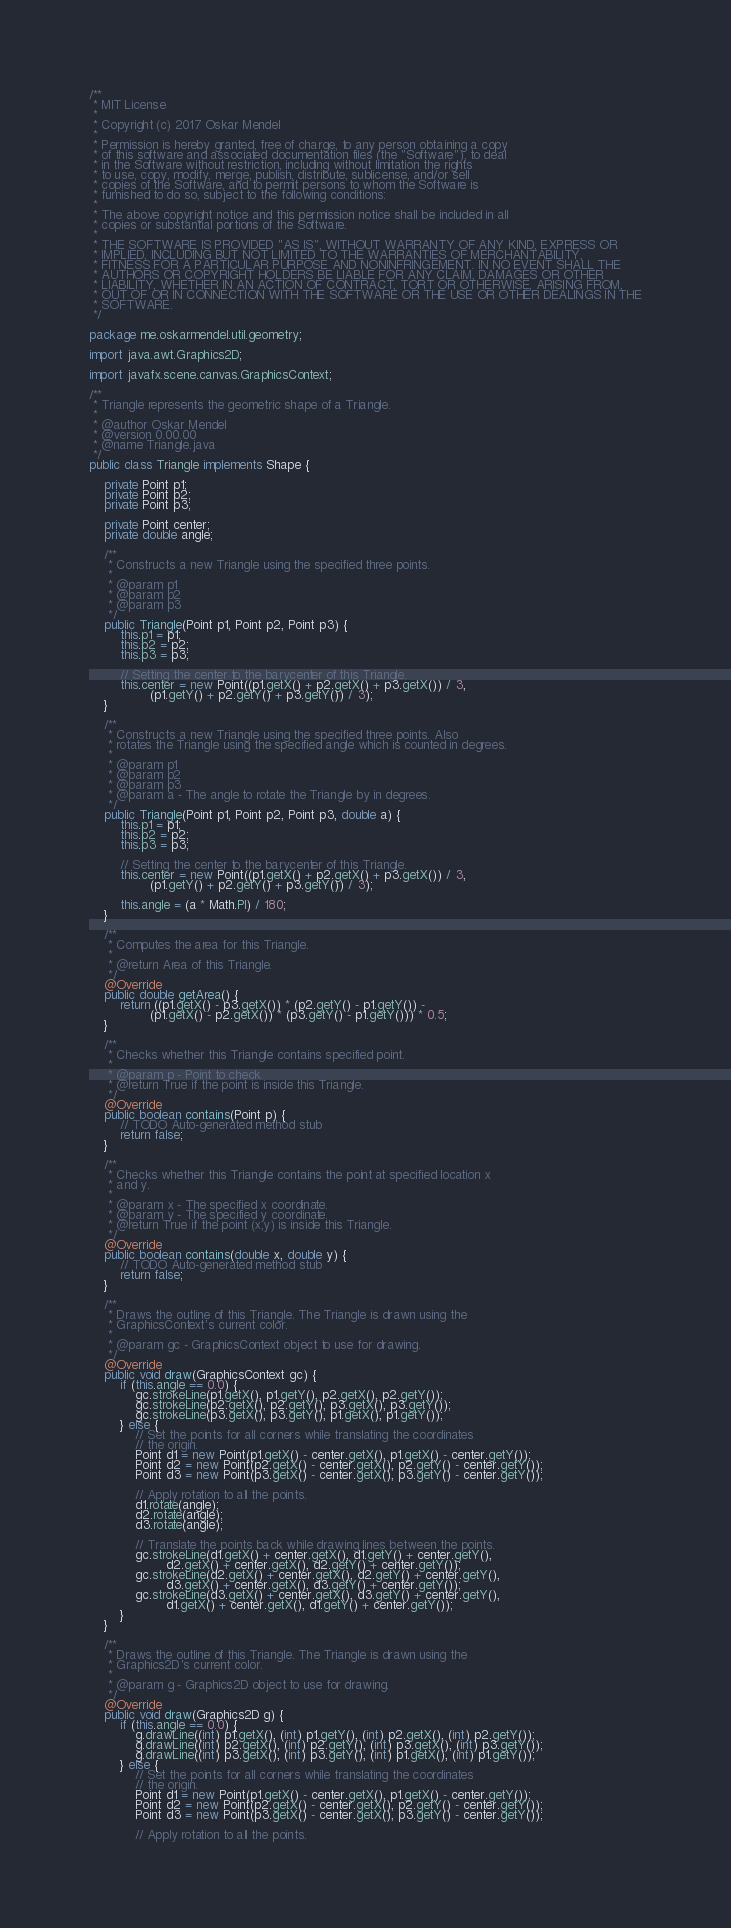<code> <loc_0><loc_0><loc_500><loc_500><_Java_>/**
 * MIT License
 * 
 * Copyright (c) 2017 Oskar Mendel
 * 
 * Permission is hereby granted, free of charge, to any person obtaining a copy
 * of this software and associated documentation files (the "Software"), to deal
 * in the Software without restriction, including without limitation the rights
 * to use, copy, modify, merge, publish, distribute, sublicense, and/or sell
 * copies of the Software, and to permit persons to whom the Software is
 * furnished to do so, subject to the following conditions:
 * 
 * The above copyright notice and this permission notice shall be included in all
 * copies or substantial portions of the Software.
 * 
 * THE SOFTWARE IS PROVIDED "AS IS", WITHOUT WARRANTY OF ANY KIND, EXPRESS OR
 * IMPLIED, INCLUDING BUT NOT LIMITED TO THE WARRANTIES OF MERCHANTABILITY,
 * FITNESS FOR A PARTICULAR PURPOSE AND NONINFRINGEMENT. IN NO EVENT SHALL THE
 * AUTHORS OR COPYRIGHT HOLDERS BE LIABLE FOR ANY CLAIM, DAMAGES OR OTHER
 * LIABILITY, WHETHER IN AN ACTION OF CONTRACT, TORT OR OTHERWISE, ARISING FROM,
 * OUT OF OR IN CONNECTION WITH THE SOFTWARE OR THE USE OR OTHER DEALINGS IN THE
 * SOFTWARE.
 */

package me.oskarmendel.util.geometry;

import java.awt.Graphics2D;

import javafx.scene.canvas.GraphicsContext;

/**
 * Triangle represents the geometric shape of a Triangle.
 * 
 * @author Oskar Mendel
 * @version 0.00.00
 * @name Triangle.java
 */
public class Triangle implements Shape {

	private Point p1;
	private Point p2;
	private Point p3;
	
	private Point center;
	private double angle;
	
	/**
	 * Constructs a new Triangle using the specified three points.
	 * 
	 * @param p1
	 * @param p2
	 * @param p3
	 */
	public Triangle(Point p1, Point p2, Point p3) {
		this.p1 = p1;
		this.p2 = p2;
		this.p3 = p3;
		
		// Setting the center to the barycenter of this Triangle.
		this.center = new Point((p1.getX() + p2.getX() + p3.getX()) / 3,
				(p1.getY() + p2.getY() + p3.getY()) / 3);
	}
	
	/**
	 * Constructs a new Triangle using the specified three points. Also
	 * rotates the Triangle using the specified angle which is counted in degrees.
	 * 
	 * @param p1
	 * @param p2
	 * @param p3
	 * @param a - The angle to rotate the Triangle by in degrees.
	 */
	public Triangle(Point p1, Point p2, Point p3, double a) {
		this.p1 = p1;
		this.p2 = p2;
		this.p3 = p3;
		
		// Setting the center to the barycenter of this Triangle.
		this.center = new Point((p1.getX() + p2.getX() + p3.getX()) / 3,
				(p1.getY() + p2.getY() + p3.getY()) / 3);
		
		this.angle = (a * Math.PI) / 180;
	}
	
	/**
	 * Computes the area for this Triangle.
	 * 
	 * @return Area of this Triangle.
	 */
	@Override
	public double getArea() {
		return ((p1.getX() - p3.getX()) * (p2.getY() - p1.getY()) -
				(p1.getX() - p2.getX()) * (p3.getY() - p1.getY())) * 0.5;
	}

	/**
	 * Checks whether this Triangle contains specified point.
	 * 
	 * @param p - Point to check.
	 * @return True if the point is inside this Triangle.
	 */
	@Override
	public boolean contains(Point p) {
		// TODO Auto-generated method stub
		return false;
	}

	/**
	 * Checks whether this Triangle contains the point at specified location x
	 * and y.
	 * 
	 * @param x - The specified x coordinate.
	 * @param y - The specified y coordinate.
	 * @return True if the point (x,y) is inside this Triangle.
	 */
	@Override
	public boolean contains(double x, double y) {
		// TODO Auto-generated method stub
		return false;
	}

	/**
	 * Draws the outline of this Triangle. The Triangle is drawn using the
	 * GraphicsContext's current color.
	 * 
	 * @param gc - GraphicsContext object to use for drawing.
	 */
	@Override
	public void draw(GraphicsContext gc) {
		if (this.angle == 0.0) {
			gc.strokeLine(p1.getX(), p1.getY(), p2.getX(), p2.getY());
			gc.strokeLine(p2.getX(), p2.getY(), p3.getX(), p3.getY());
			gc.strokeLine(p3.getX(), p3.getY(), p1.getX(), p1.getY());
		} else {
			// Set the points for all corners while translating the coordinates
			// the origin.
			Point d1 = new Point(p1.getX() - center.getX(), p1.getX() - center.getY());
			Point d2 = new Point(p2.getX() - center.getX(), p2.getY() - center.getY());
			Point d3 = new Point(p3.getX() - center.getX(), p3.getY() - center.getY());
			
			// Apply rotation to all the points.
			d1.rotate(angle);
			d2.rotate(angle);
			d3.rotate(angle);
			
			// Translate the points back while drawing lines between the points.
			gc.strokeLine(d1.getX() + center.getX(), d1.getY() + center.getY(), 
					d2.getX() + center.getX(), d2.getY() + center.getY());
			gc.strokeLine(d2.getX() + center.getX(), d2.getY() + center.getY(), 
					d3.getX() + center.getX(), d3.getY() + center.getY());
			gc.strokeLine(d3.getX() + center.getX(), d3.getY() + center.getY(), 
					d1.getX() + center.getX(), d1.getY() + center.getY());
		}
	}

	/**
	 * Draws the outline of this Triangle. The Triangle is drawn using the
	 * Graphics2D's current color.
	 * 
	 * @param g - Graphics2D object to use for drawing.
	 */
	@Override
	public void draw(Graphics2D g) {
		if (this.angle == 0.0) {
			g.drawLine((int) p1.getX(), (int) p1.getY(), (int) p2.getX(), (int) p2.getY());
			g.drawLine((int) p2.getX(), (int) p2.getY(), (int) p3.getX(), (int) p3.getY());
			g.drawLine((int) p3.getX(), (int) p3.getY(), (int) p1.getX(), (int) p1.getY());
		} else {
			// Set the points for all corners while translating the coordinates
			// the origin.
			Point d1 = new Point(p1.getX() - center.getX(), p1.getX() - center.getY());
			Point d2 = new Point(p2.getX() - center.getX(), p2.getY() - center.getY());
			Point d3 = new Point(p3.getX() - center.getX(), p3.getY() - center.getY());
			
			// Apply rotation to all the points.</code> 